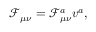Convert formula to latex. <formula><loc_0><loc_0><loc_500><loc_500>\mathcal { F } _ { \mu \nu } = \mathcal { F } _ { \mu \nu } ^ { a } v ^ { a } ,</formula> 